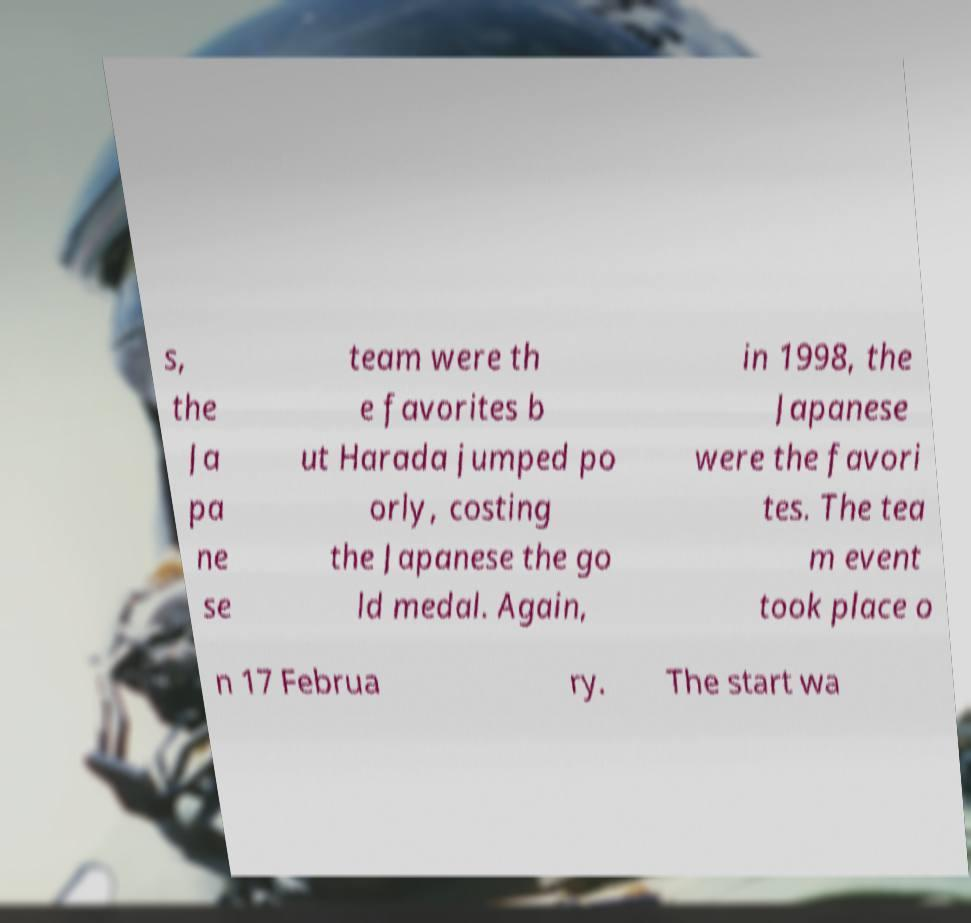Can you accurately transcribe the text from the provided image for me? s, the Ja pa ne se team were th e favorites b ut Harada jumped po orly, costing the Japanese the go ld medal. Again, in 1998, the Japanese were the favori tes. The tea m event took place o n 17 Februa ry. The start wa 